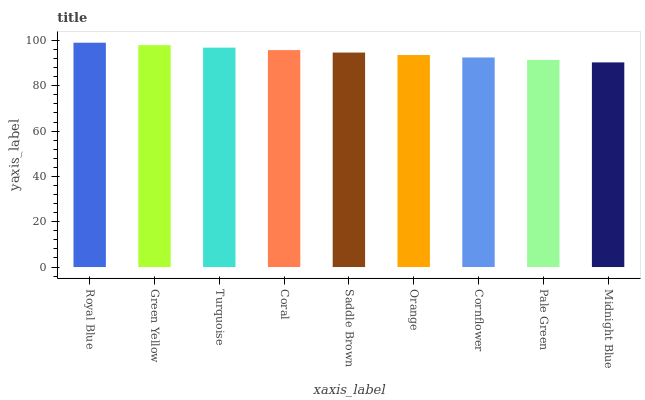Is Green Yellow the minimum?
Answer yes or no. No. Is Green Yellow the maximum?
Answer yes or no. No. Is Royal Blue greater than Green Yellow?
Answer yes or no. Yes. Is Green Yellow less than Royal Blue?
Answer yes or no. Yes. Is Green Yellow greater than Royal Blue?
Answer yes or no. No. Is Royal Blue less than Green Yellow?
Answer yes or no. No. Is Saddle Brown the high median?
Answer yes or no. Yes. Is Saddle Brown the low median?
Answer yes or no. Yes. Is Cornflower the high median?
Answer yes or no. No. Is Coral the low median?
Answer yes or no. No. 